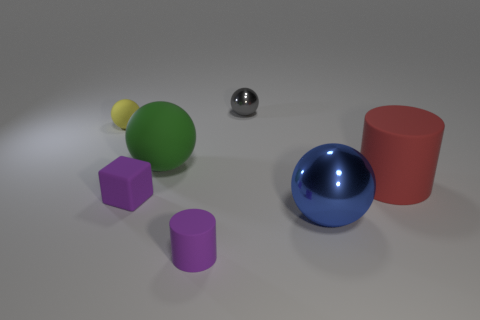How many other objects are there of the same color as the matte cube?
Keep it short and to the point. 1. Are there more large metal objects behind the gray metallic ball than green rubber things that are in front of the big blue metallic object?
Keep it short and to the point. No. Are there any other things that have the same size as the yellow rubber thing?
Your response must be concise. Yes. What number of blocks are either blue things or large green objects?
Your answer should be very brief. 0. How many things are big blue spheres behind the small purple matte cylinder or big cyan balls?
Provide a succinct answer. 1. The small purple rubber thing behind the metal thing that is right of the small thing behind the tiny yellow sphere is what shape?
Provide a succinct answer. Cube. How many other tiny gray metallic objects are the same shape as the tiny gray metal object?
Make the answer very short. 0. There is a cube that is the same color as the small cylinder; what is it made of?
Your response must be concise. Rubber. Does the small gray ball have the same material as the big blue ball?
Make the answer very short. Yes. There is a cylinder that is on the right side of the metallic object that is to the left of the blue sphere; what number of metal things are in front of it?
Offer a very short reply. 1. 